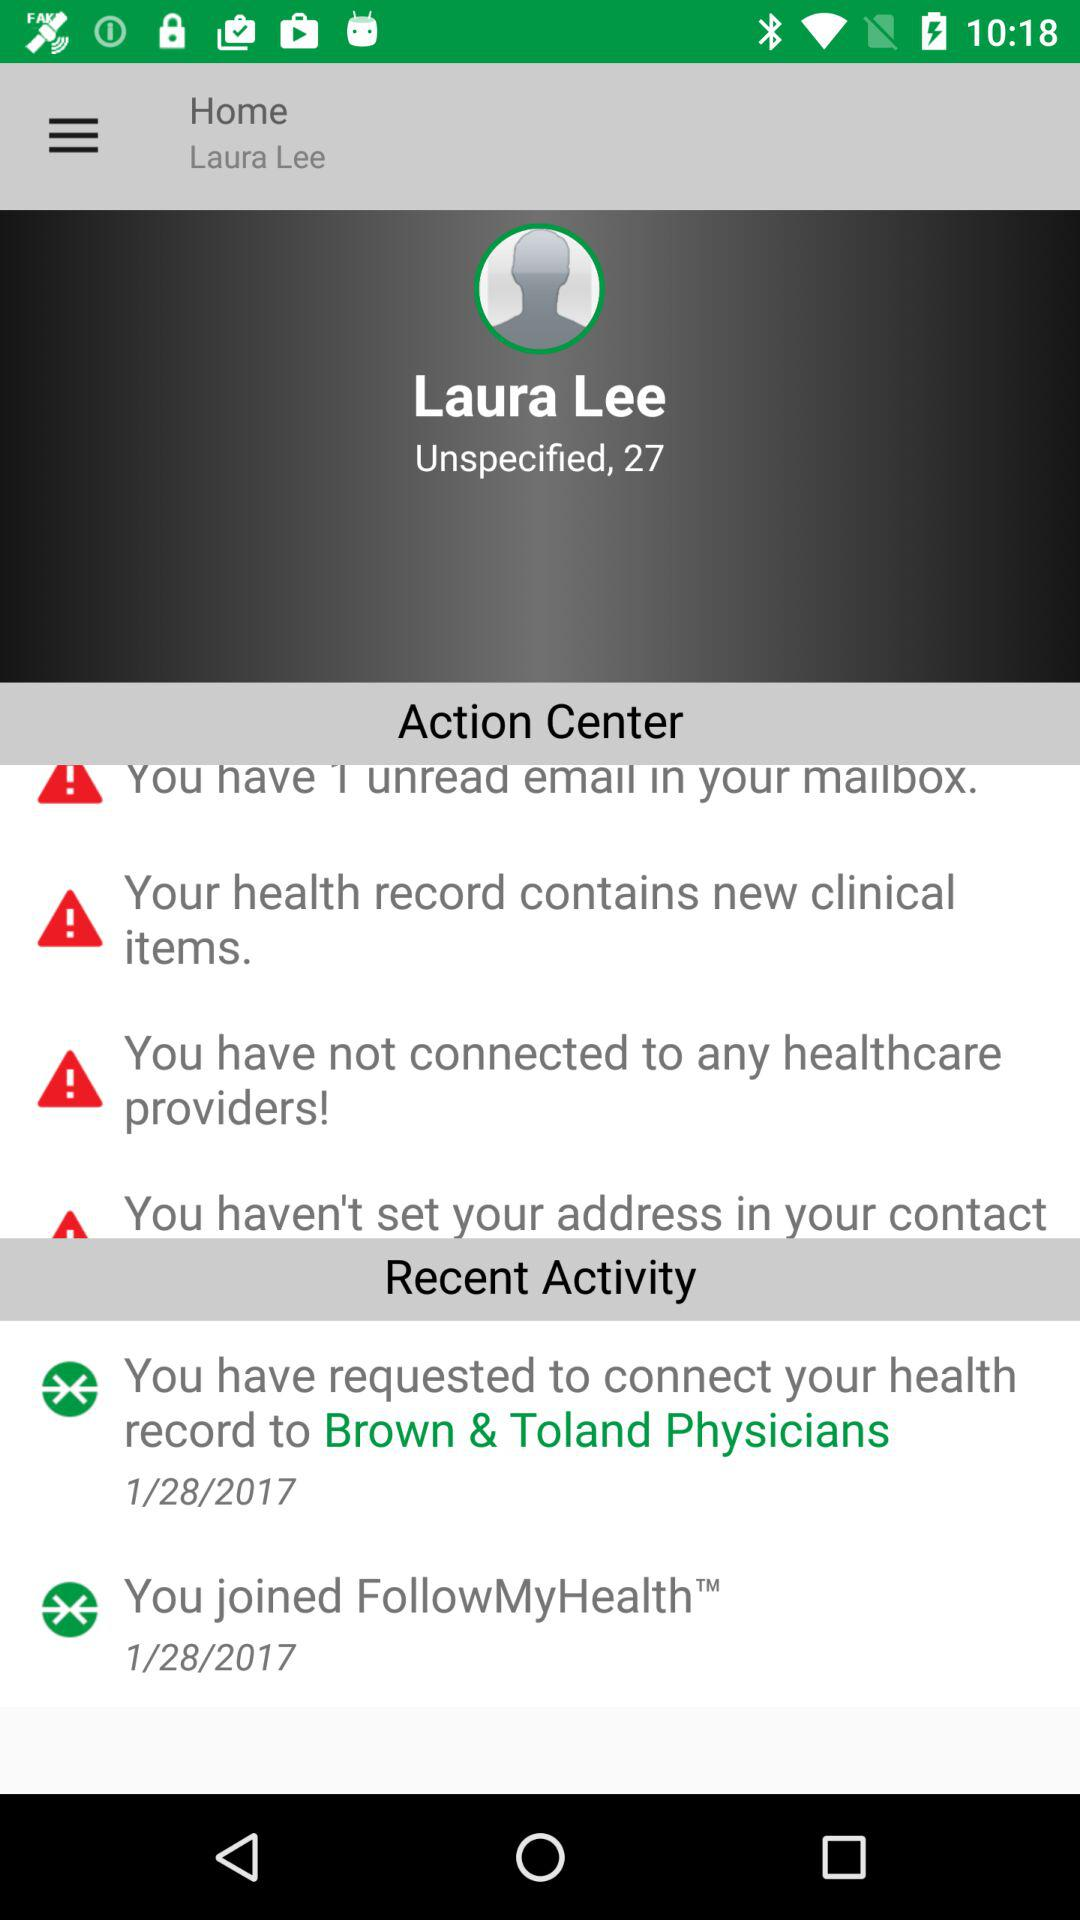What are the recent activities? The recent activities are "You have requested to connect your health record to Brown & Toland Physicians" and "You joined FollowMyHealth". 